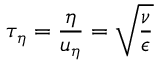<formula> <loc_0><loc_0><loc_500><loc_500>\tau _ { \eta } = \frac { \eta } { u _ { \eta } } = \sqrt { \frac { \nu } { \epsilon } }</formula> 